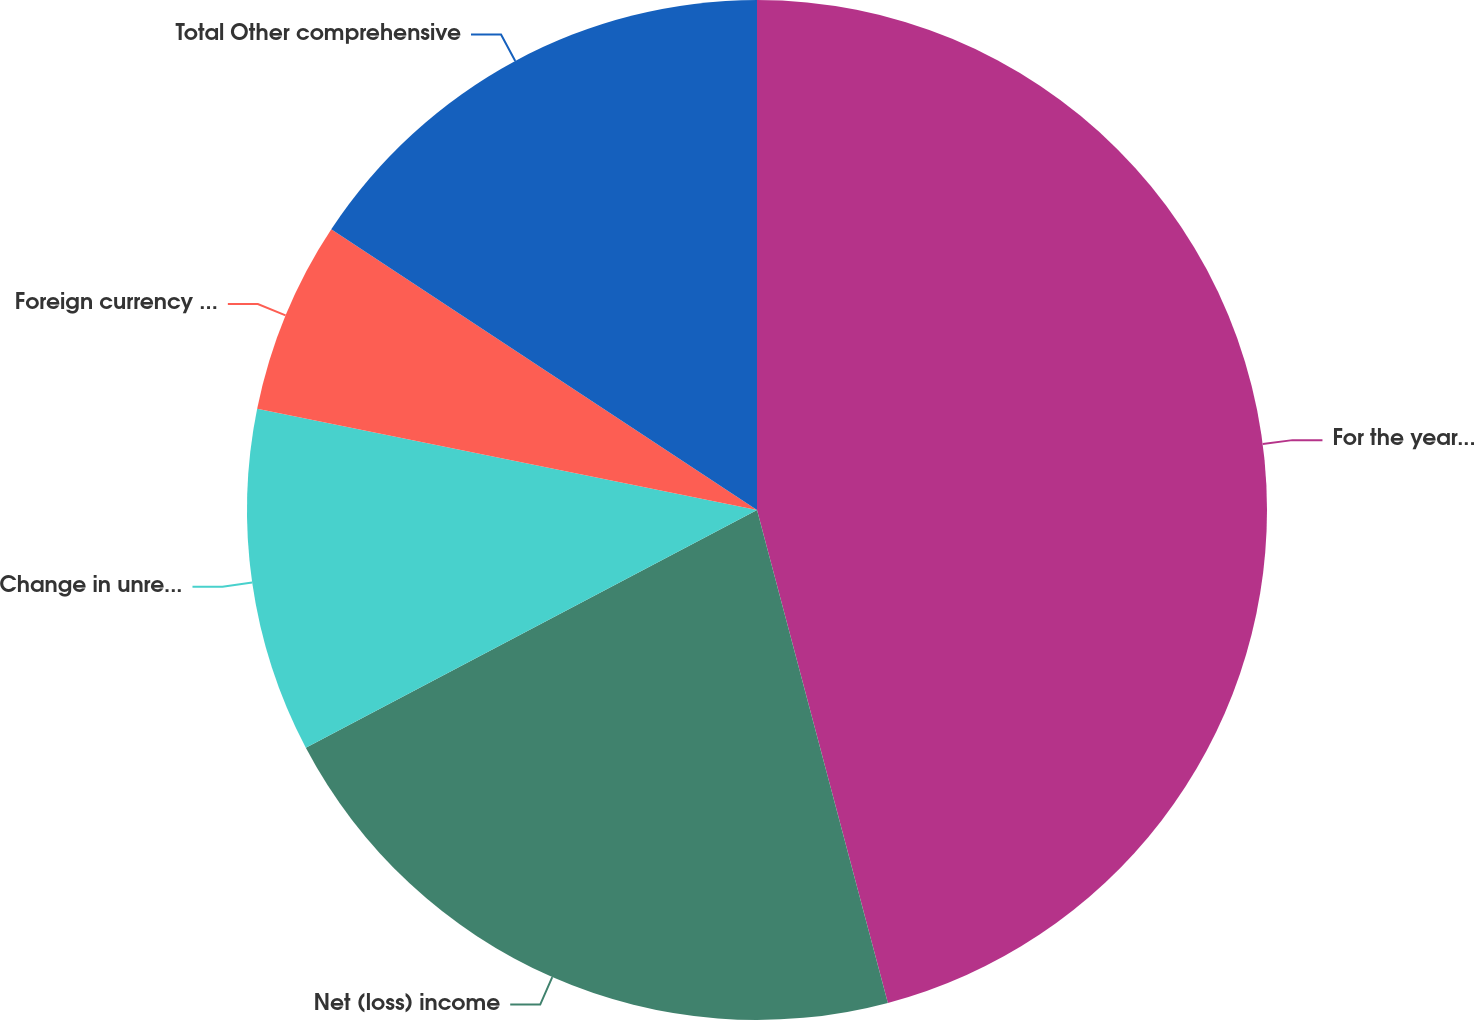<chart> <loc_0><loc_0><loc_500><loc_500><pie_chart><fcel>For the year ended December 31<fcel>Net (loss) income<fcel>Change in unrecognized net<fcel>Foreign currency translation<fcel>Total Other comprehensive<nl><fcel>45.87%<fcel>21.41%<fcel>10.9%<fcel>6.1%<fcel>15.72%<nl></chart> 